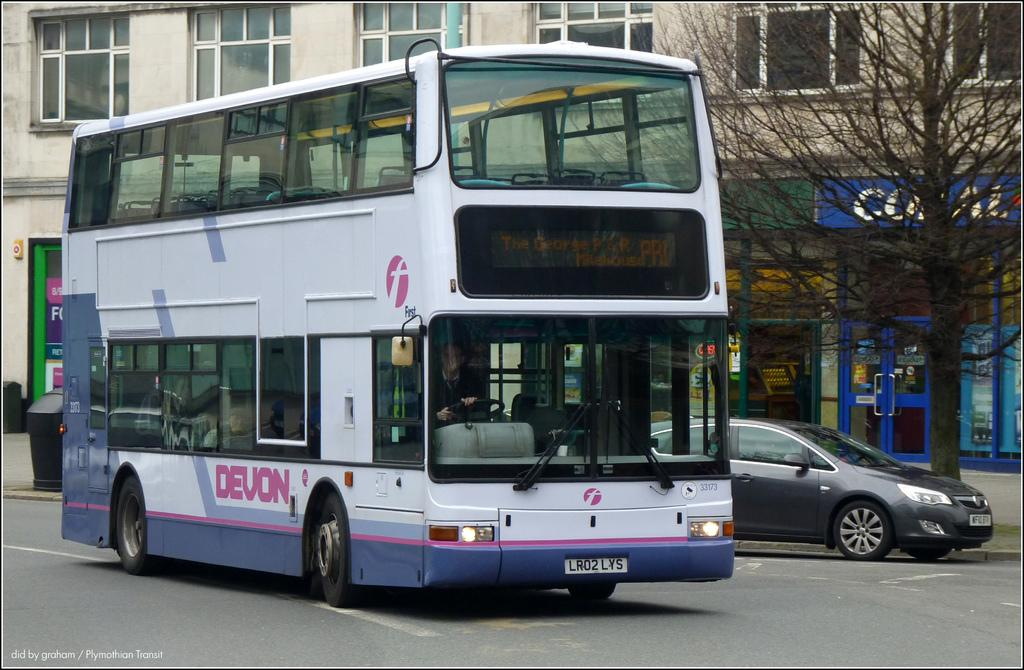What is the main subject of the image? The main subject of the image is a bus. What is the bus doing in the image? The bus is moving on the road in the image. What is the color of the bus? The bus is white in color. What can be seen on the right side of the image? There is a tree on the right side of the image. What is located in the middle of the image? There is a building in the middle of the image. What type of plant is growing inside the bus in the image? There is no plant growing inside the bus in the image. What is the condition of the tub on the left side of the image? There is no tub present in the image. 